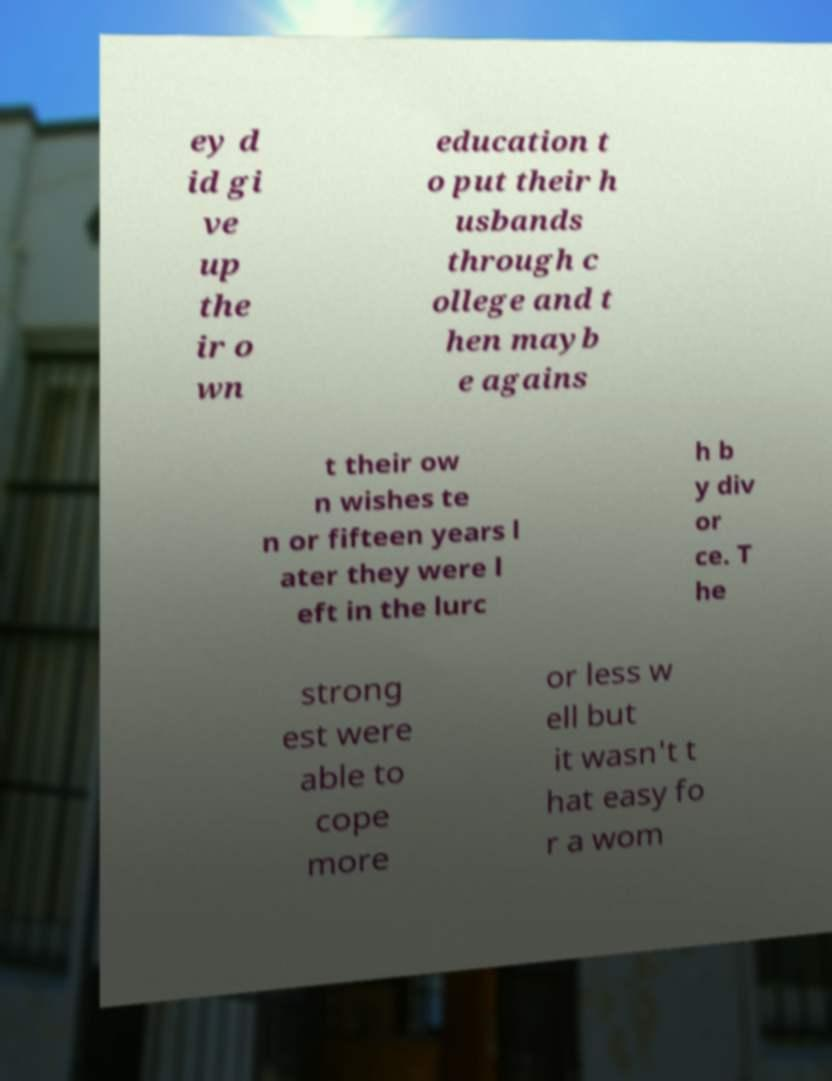There's text embedded in this image that I need extracted. Can you transcribe it verbatim? ey d id gi ve up the ir o wn education t o put their h usbands through c ollege and t hen mayb e agains t their ow n wishes te n or fifteen years l ater they were l eft in the lurc h b y div or ce. T he strong est were able to cope more or less w ell but it wasn't t hat easy fo r a wom 